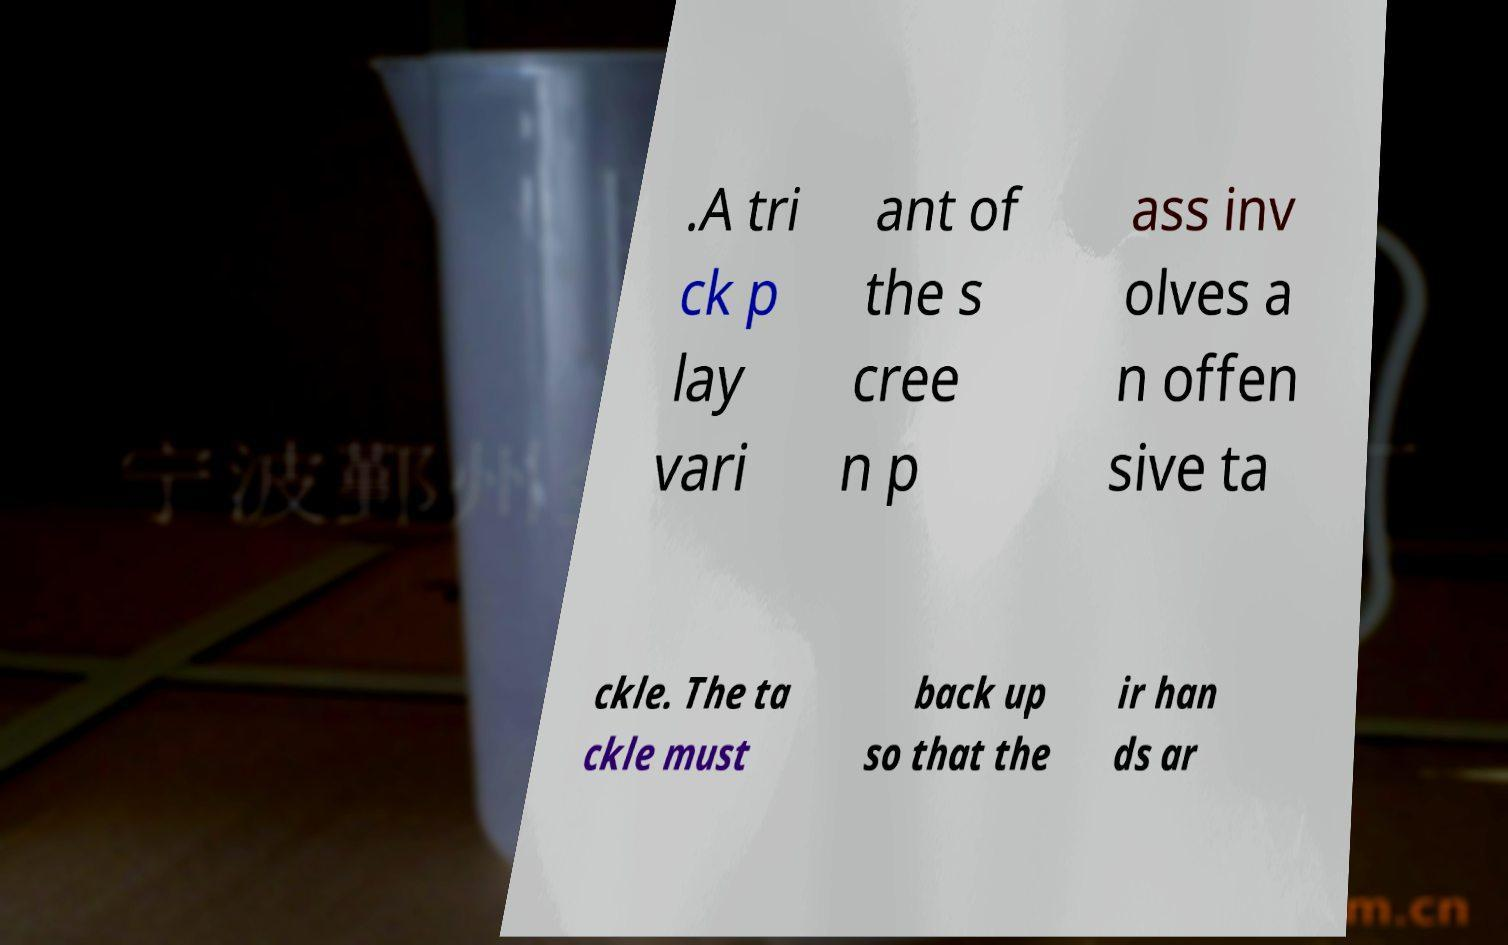Please identify and transcribe the text found in this image. .A tri ck p lay vari ant of the s cree n p ass inv olves a n offen sive ta ckle. The ta ckle must back up so that the ir han ds ar 